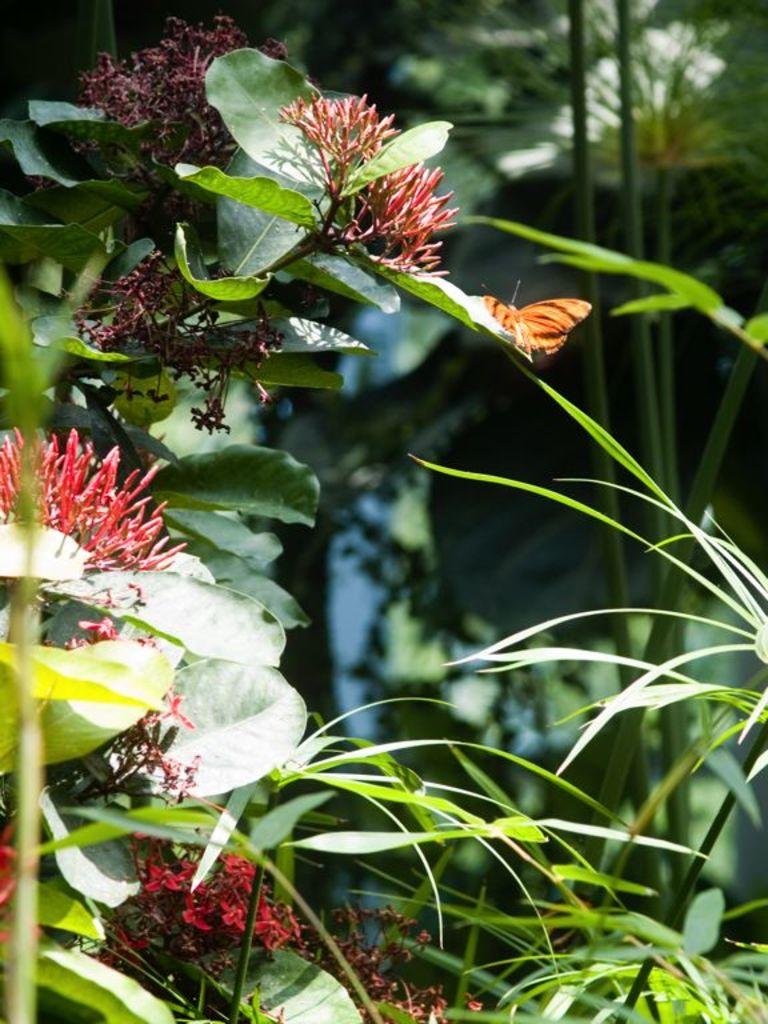What type of living organisms can be seen in the image? Plants can be seen in the image. What specific features do the plants have? The plants have flowers and leaves. Can you describe any additional elements in the image? There is a butterfly on a leaf in the image. What can be seen in the background of the image? Plants and trees are visible in the background of the image. What is the price of the desk in the image? There is no desk present in the image, so it is not possible to determine its price. 